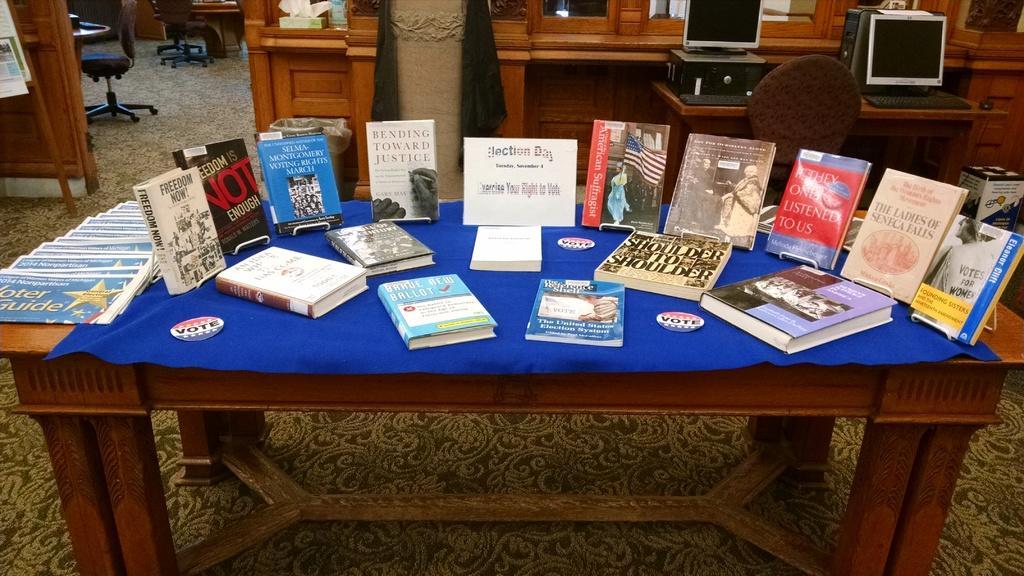In one or two sentences, can you explain what this image depicts? This is the picture of a table on which there is a blue mat and some books on the table and behind there are some desk on which there are some systems. 